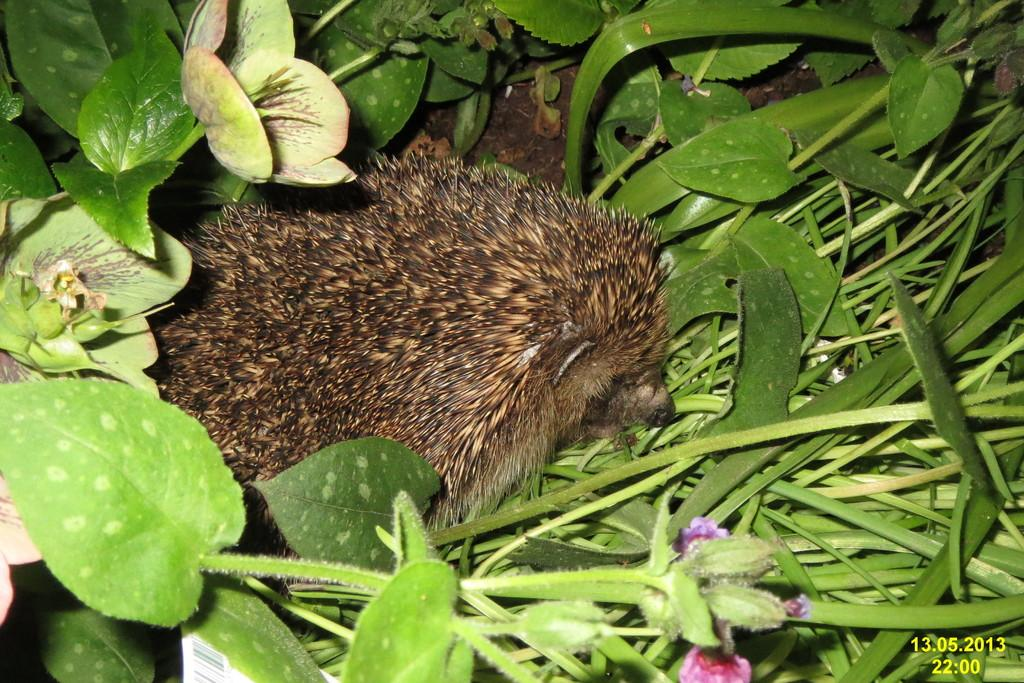What type of animal can be seen in the image? There is an animal present in the image, but its specific type cannot be determined from the provided facts. Where is the animal located in the image? The animal is on the ground in the image. What type of vegetation is visible in the image? There is grass and plants present in the image. What color is the chalk used to draw on the animal in the image? There is no chalk or drawing on the animal in the image; it is simply an animal on the ground. How much grain is being consumed by the animal in the image? There is no grain present in the image, so it cannot be determined if the animal is consuming any. 